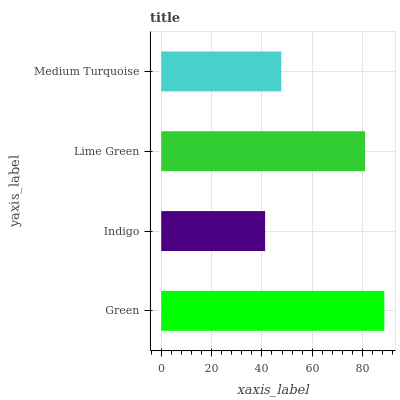Is Indigo the minimum?
Answer yes or no. Yes. Is Green the maximum?
Answer yes or no. Yes. Is Lime Green the minimum?
Answer yes or no. No. Is Lime Green the maximum?
Answer yes or no. No. Is Lime Green greater than Indigo?
Answer yes or no. Yes. Is Indigo less than Lime Green?
Answer yes or no. Yes. Is Indigo greater than Lime Green?
Answer yes or no. No. Is Lime Green less than Indigo?
Answer yes or no. No. Is Lime Green the high median?
Answer yes or no. Yes. Is Medium Turquoise the low median?
Answer yes or no. Yes. Is Indigo the high median?
Answer yes or no. No. Is Lime Green the low median?
Answer yes or no. No. 